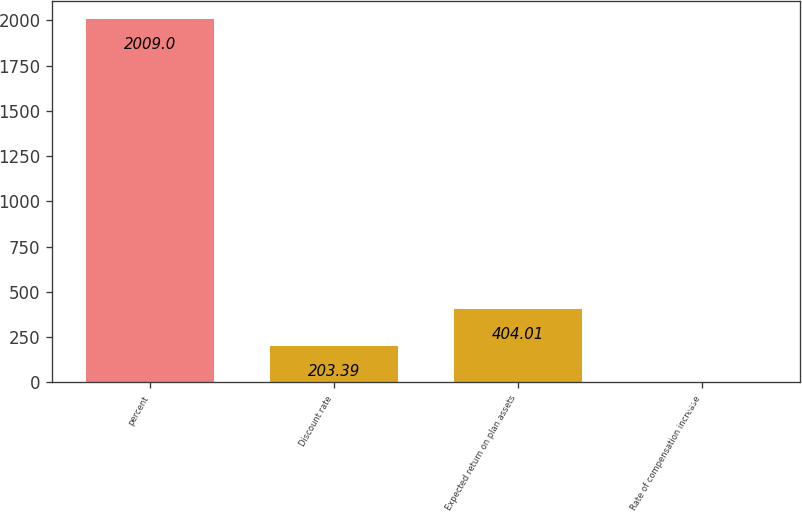Convert chart. <chart><loc_0><loc_0><loc_500><loc_500><bar_chart><fcel>percent<fcel>Discount rate<fcel>Expected return on plan assets<fcel>Rate of compensation increase<nl><fcel>2009<fcel>203.39<fcel>404.01<fcel>2.77<nl></chart> 